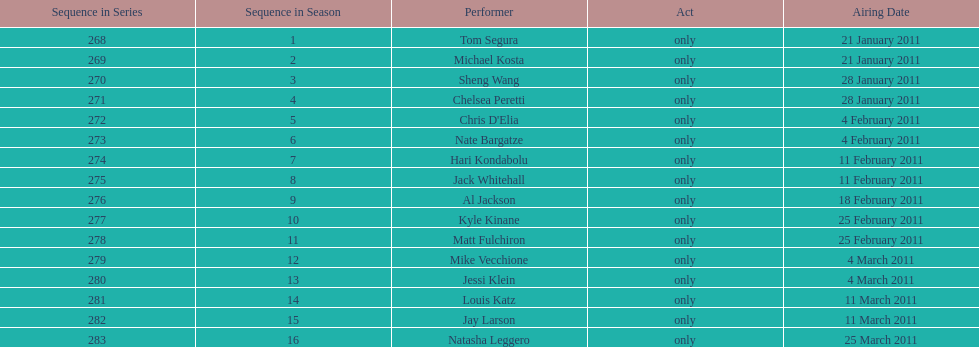How many comedians made their only appearance on comedy central presents in season 15? 16. 